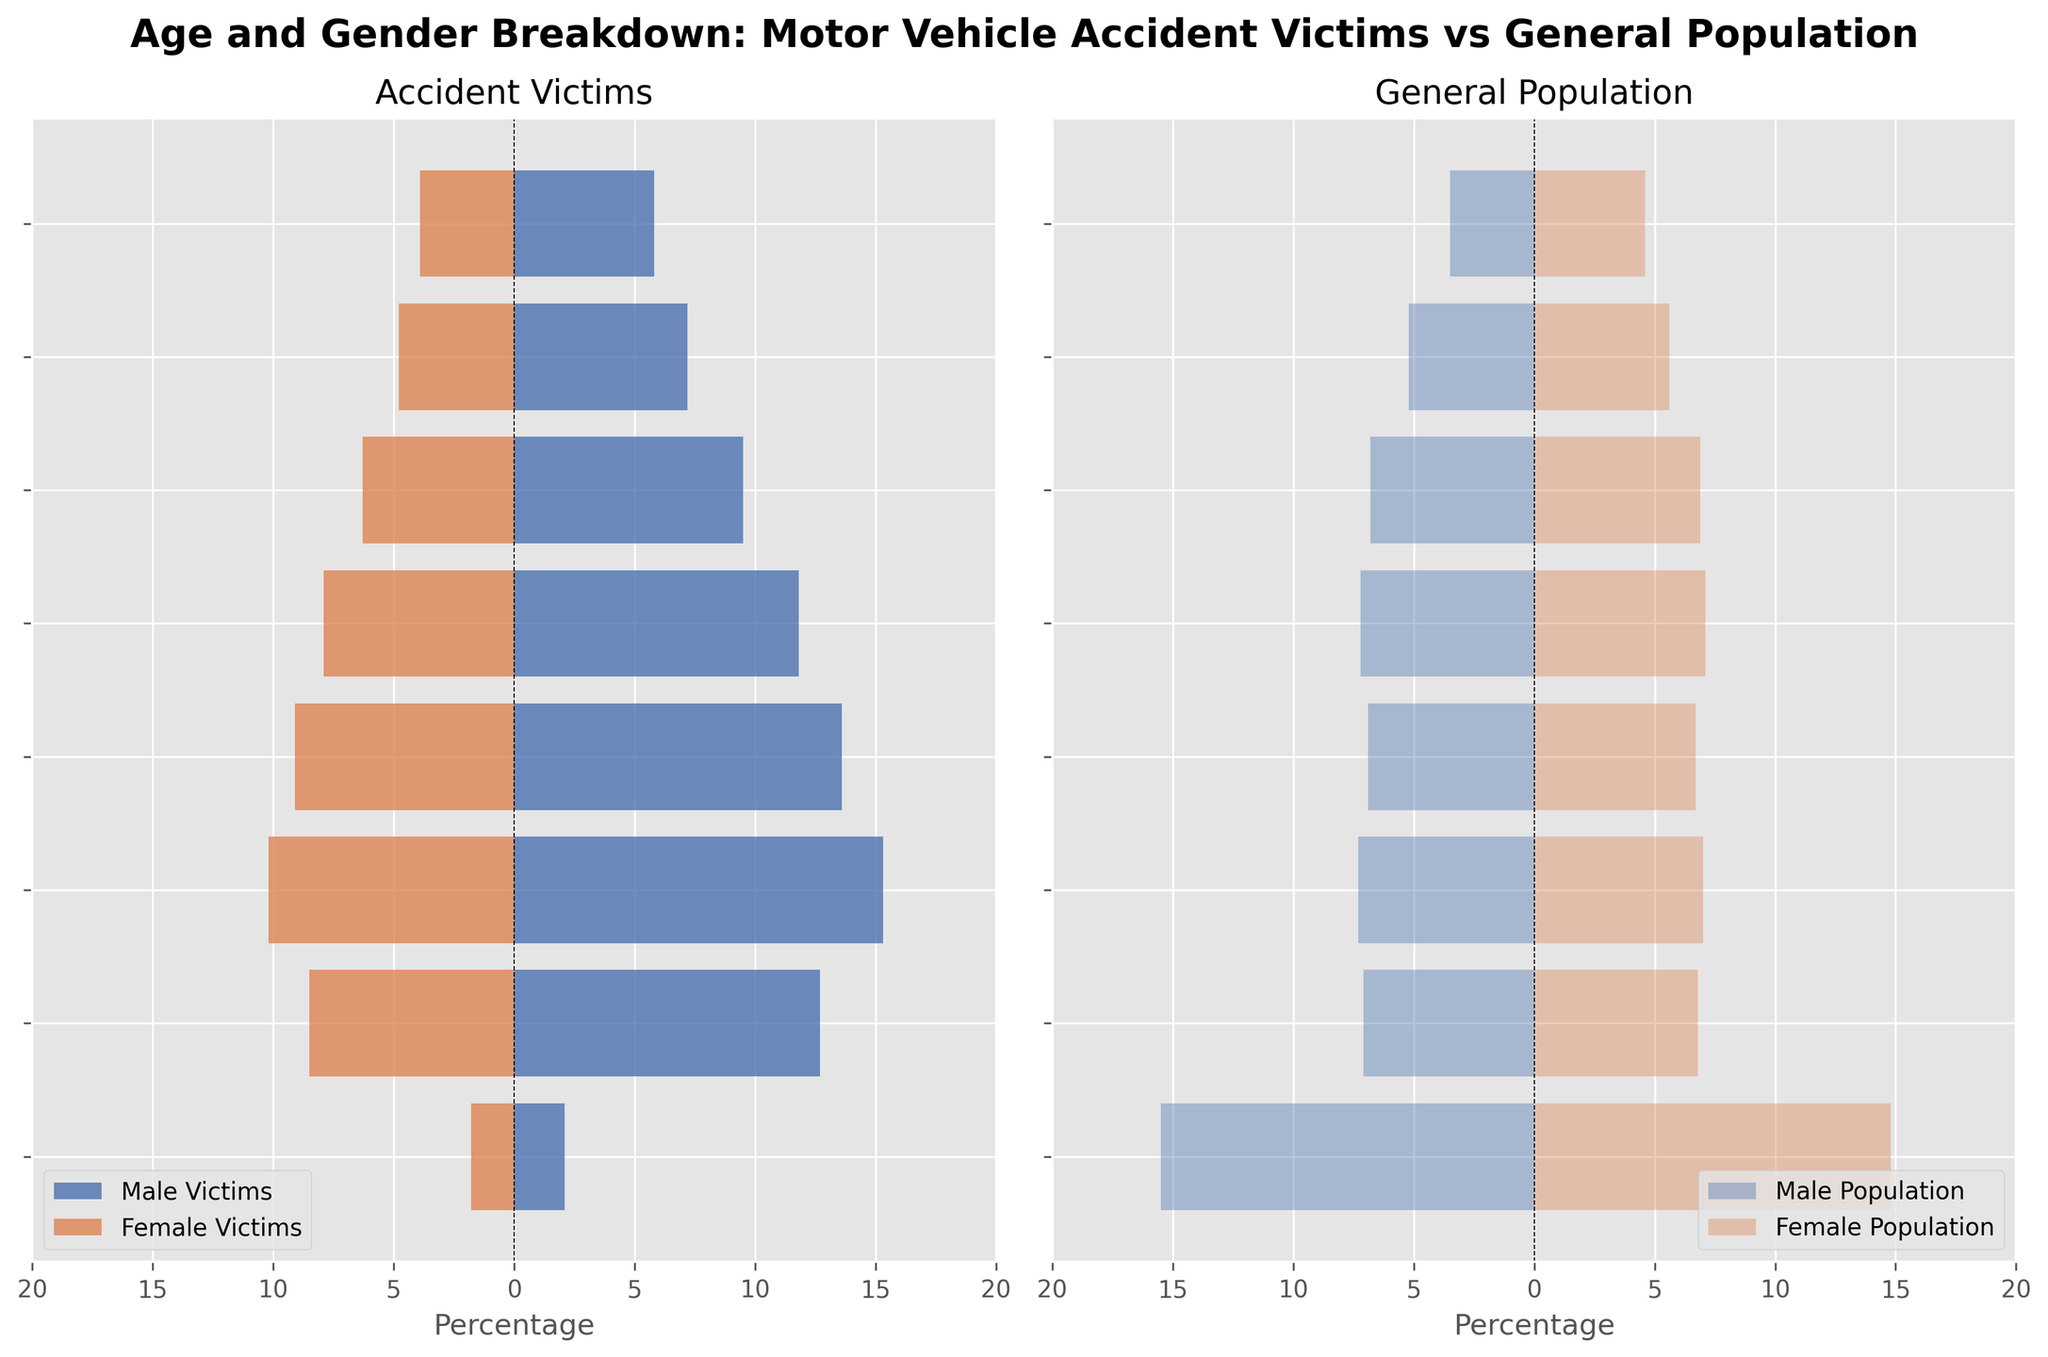What is the title of the figure? The title of the plot is displayed at the top of the figure, which is clearly written in a bold font for easy identification.
Answer: Age and Gender Breakdown: Motor Vehicle Accident Victims vs General Population Which gender has a higher percentage of motor vehicle accident victims in the 25-34 age group? In the "Accident Victims" subplot, the male victims bar for the 25-34 age group is longer than the female victims bar, indicating a higher percentage of male victims in this age group.
Answer: Male How do the percentages of male and female accident victims in the 15-24 age group compare to the general population in the same age group? The "Accident Victims" subplot shows the male victims percentage as -12.7% and female victims as 8.5%. In the "General Population" subplot, male and female populations are -7.1% and 6.8%, respectively. Both groups of victims are higher than their general population counterparts.
Answer: Both are higher What is the combined percentage of male and female victims in the 45-54 age group? In the "Accident Victims" subplot, the male victims percentage is -11.8% and the female victims percentage is 7.9%. Summing the absolute percentages gives 11.8 + 7.9.
Answer: 19.7% In the 75+ age group, which group's bar extends further, male accident victims or male general population? Comparing the lengths of the bars in the "Accident Victims" and "General Population" subplots, the male accident victims percentage is -5.8%, while the male general population is -3.5%. The male accident victims bar extends further since 5.8 > 3.5.
Answer: Male accident victims What is the difference in the percentage of female accident victims between the 35-44 and 55-64 age groups? Subtract the 55-64 percentage from the 35-44 percentage in the "Accident Victims" subplot: 9.1 - 6.3.
Answer: 2.8 In the 0-14 age group, which has a higher percentage, female accident victims or female general population? From the "Accident Victims" subplot, female victims percentage is 1.8. In the "General Population" subplot, female population percentage is 14.8. The female general population percentage is higher.
Answer: Female general population 